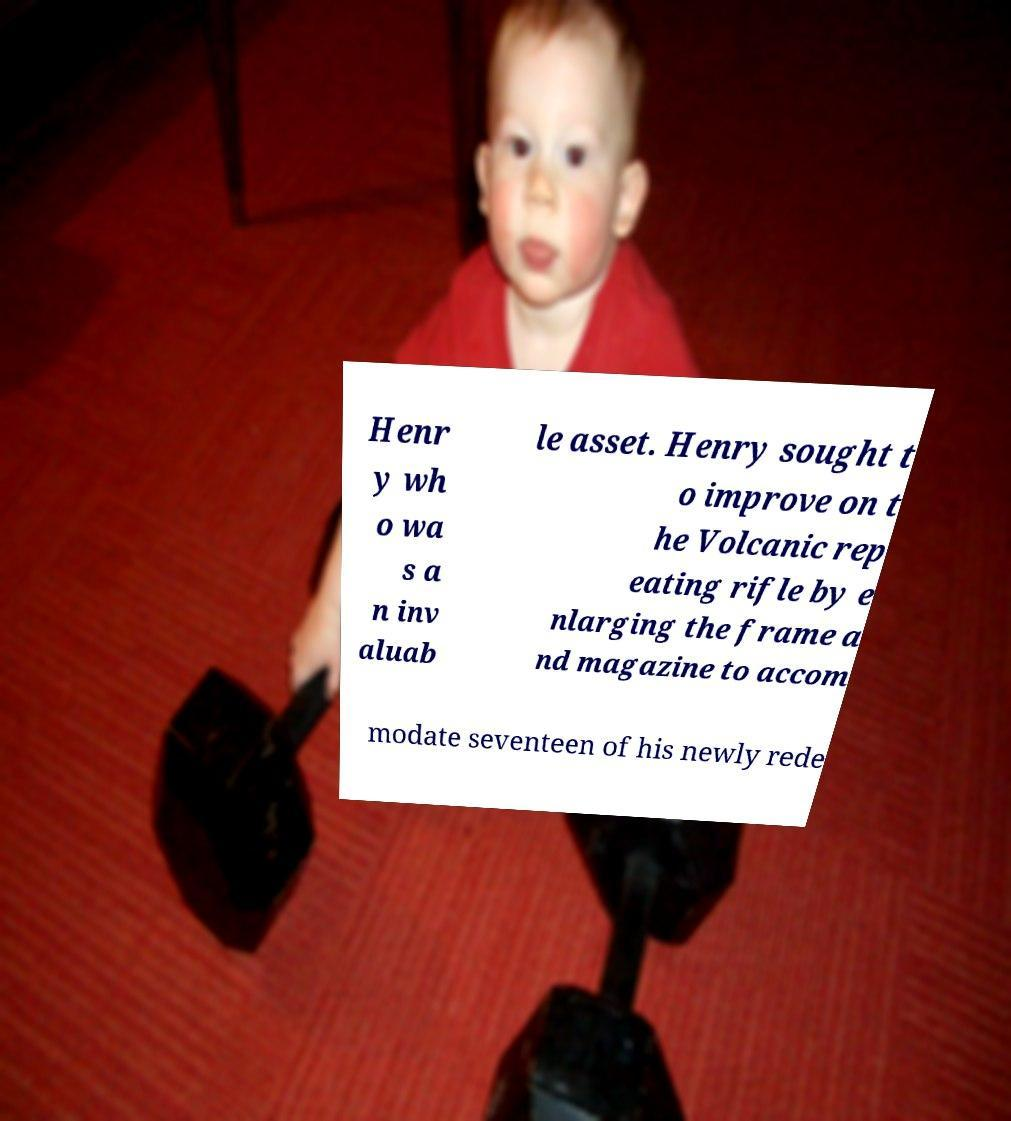There's text embedded in this image that I need extracted. Can you transcribe it verbatim? Henr y wh o wa s a n inv aluab le asset. Henry sought t o improve on t he Volcanic rep eating rifle by e nlarging the frame a nd magazine to accom modate seventeen of his newly rede 